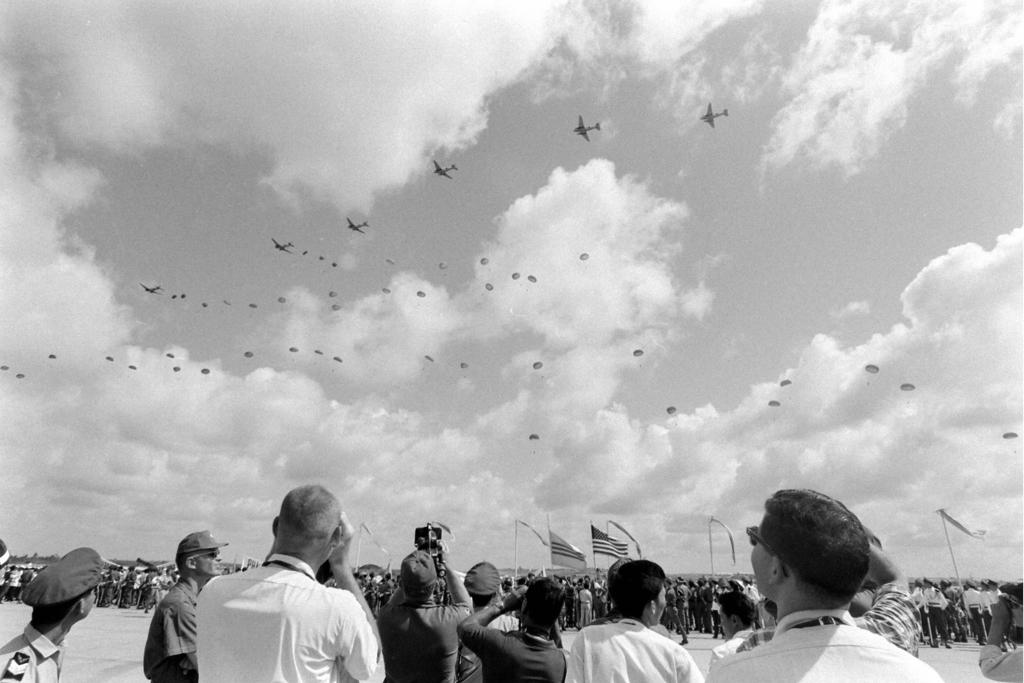What is happening on the ground in the image? There are many people on the ground in the image. What can be seen besides the people on the ground? There are flags in the image. What are the people doing while looking at the sky? People are looking at the sky in the image. What is visible in the sky besides the clouds? There are flights visible in the sky. What type of laborer is working on the hand in the image? There is no laborer or hand present in the image. What is the best way to reach the top of the flagpole in the image? The image does not provide enough information to determine the best way to reach the top of the flagpole. 